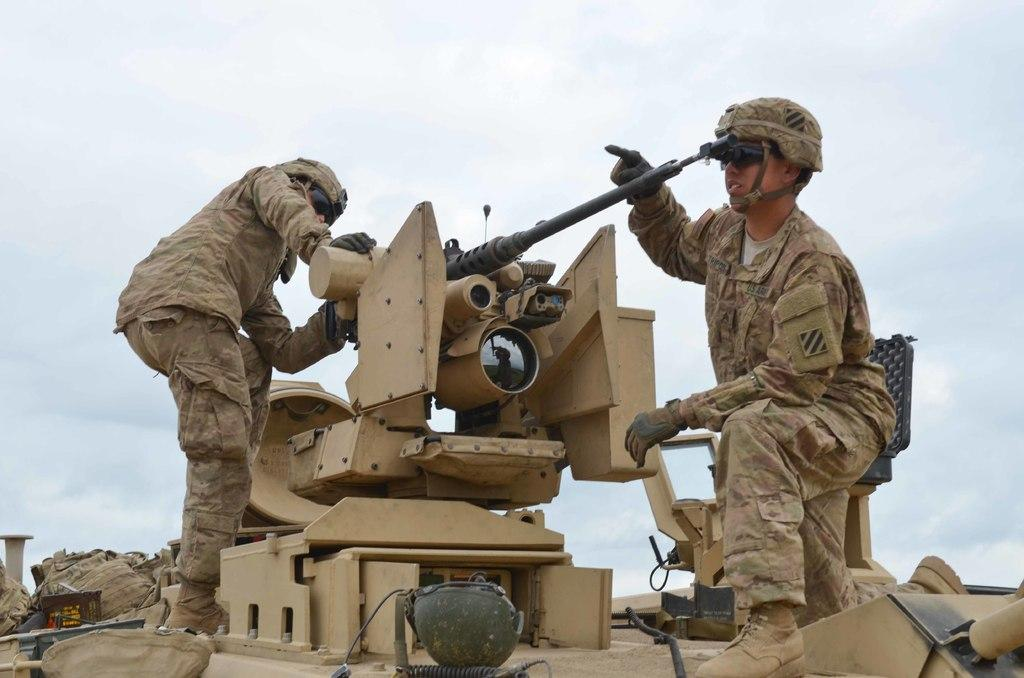Who is present in the image? There are two military persons in the image. What are the military persons standing on? The military persons are on a tanker. What protective gear can be seen in the image? There are helmets in the image. What items are on the tanker? There are bags on the tanker. What can be seen in the background of the image? The sky is visible in the image. What type of powder is being used by the military persons in the image? There is no powder visible in the image. The military persons are wearing helmets and standing on a tanker, but there is no indication of any powder being used. 